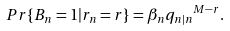<formula> <loc_0><loc_0><loc_500><loc_500>P r \{ B _ { n } = 1 | r _ { n } = r \} = \beta _ { n } { q _ { n | n } } ^ { M - r } .</formula> 